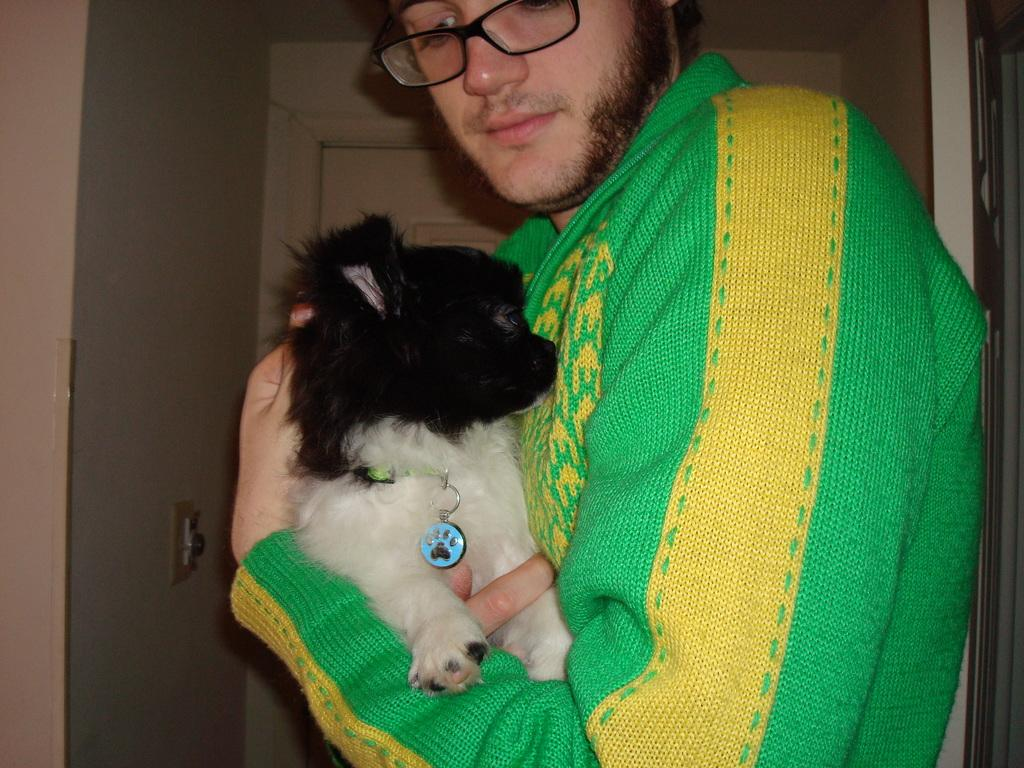What is the main subject of the image? There is a person in the image. What is the person wearing? The person is wearing a green sweater. What is the person holding? The person is holding a dog. What accessory is the person wearing? The person is wearing spectacles. What can be seen in the background of the image? There is a door in the background of the image. What type of produce is being displayed on the stage in the image? There is no stage or produce present in the image. What kind of pie is the person holding in the image? The person is holding a dog, not a pie, in the image. 